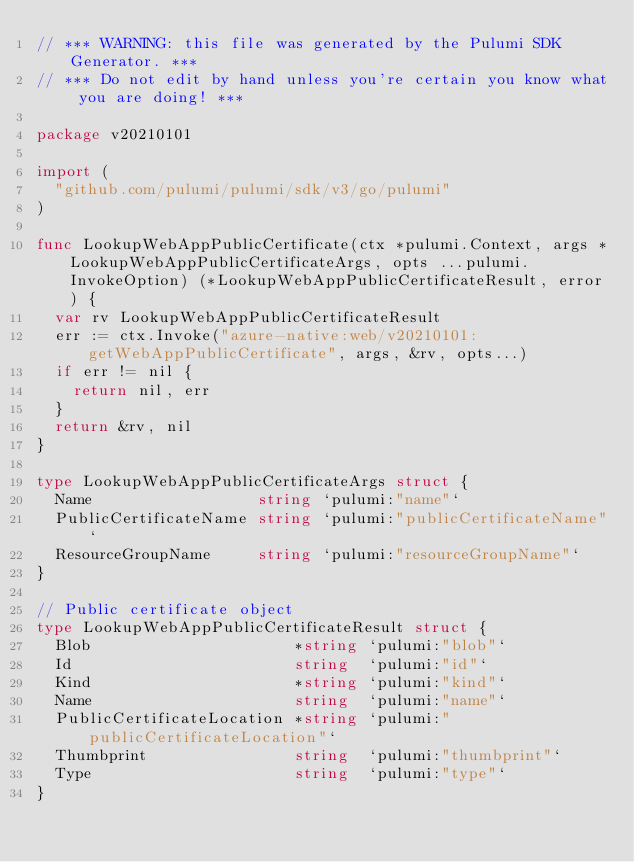Convert code to text. <code><loc_0><loc_0><loc_500><loc_500><_Go_>// *** WARNING: this file was generated by the Pulumi SDK Generator. ***
// *** Do not edit by hand unless you're certain you know what you are doing! ***

package v20210101

import (
	"github.com/pulumi/pulumi/sdk/v3/go/pulumi"
)

func LookupWebAppPublicCertificate(ctx *pulumi.Context, args *LookupWebAppPublicCertificateArgs, opts ...pulumi.InvokeOption) (*LookupWebAppPublicCertificateResult, error) {
	var rv LookupWebAppPublicCertificateResult
	err := ctx.Invoke("azure-native:web/v20210101:getWebAppPublicCertificate", args, &rv, opts...)
	if err != nil {
		return nil, err
	}
	return &rv, nil
}

type LookupWebAppPublicCertificateArgs struct {
	Name                  string `pulumi:"name"`
	PublicCertificateName string `pulumi:"publicCertificateName"`
	ResourceGroupName     string `pulumi:"resourceGroupName"`
}

// Public certificate object
type LookupWebAppPublicCertificateResult struct {
	Blob                      *string `pulumi:"blob"`
	Id                        string  `pulumi:"id"`
	Kind                      *string `pulumi:"kind"`
	Name                      string  `pulumi:"name"`
	PublicCertificateLocation *string `pulumi:"publicCertificateLocation"`
	Thumbprint                string  `pulumi:"thumbprint"`
	Type                      string  `pulumi:"type"`
}
</code> 